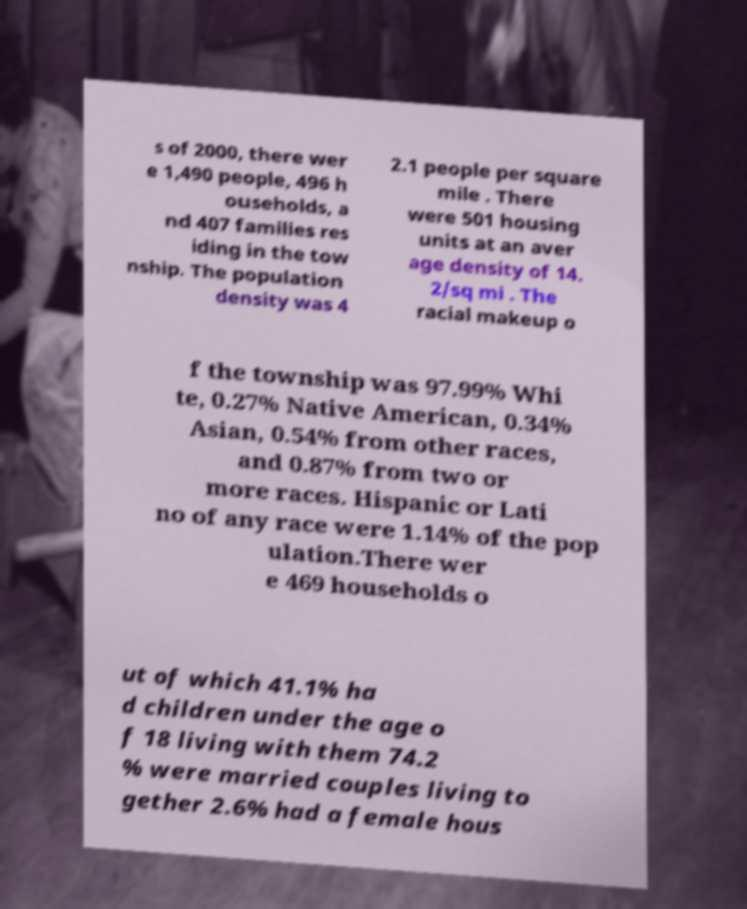I need the written content from this picture converted into text. Can you do that? s of 2000, there wer e 1,490 people, 496 h ouseholds, a nd 407 families res iding in the tow nship. The population density was 4 2.1 people per square mile . There were 501 housing units at an aver age density of 14. 2/sq mi . The racial makeup o f the township was 97.99% Whi te, 0.27% Native American, 0.34% Asian, 0.54% from other races, and 0.87% from two or more races. Hispanic or Lati no of any race were 1.14% of the pop ulation.There wer e 469 households o ut of which 41.1% ha d children under the age o f 18 living with them 74.2 % were married couples living to gether 2.6% had a female hous 